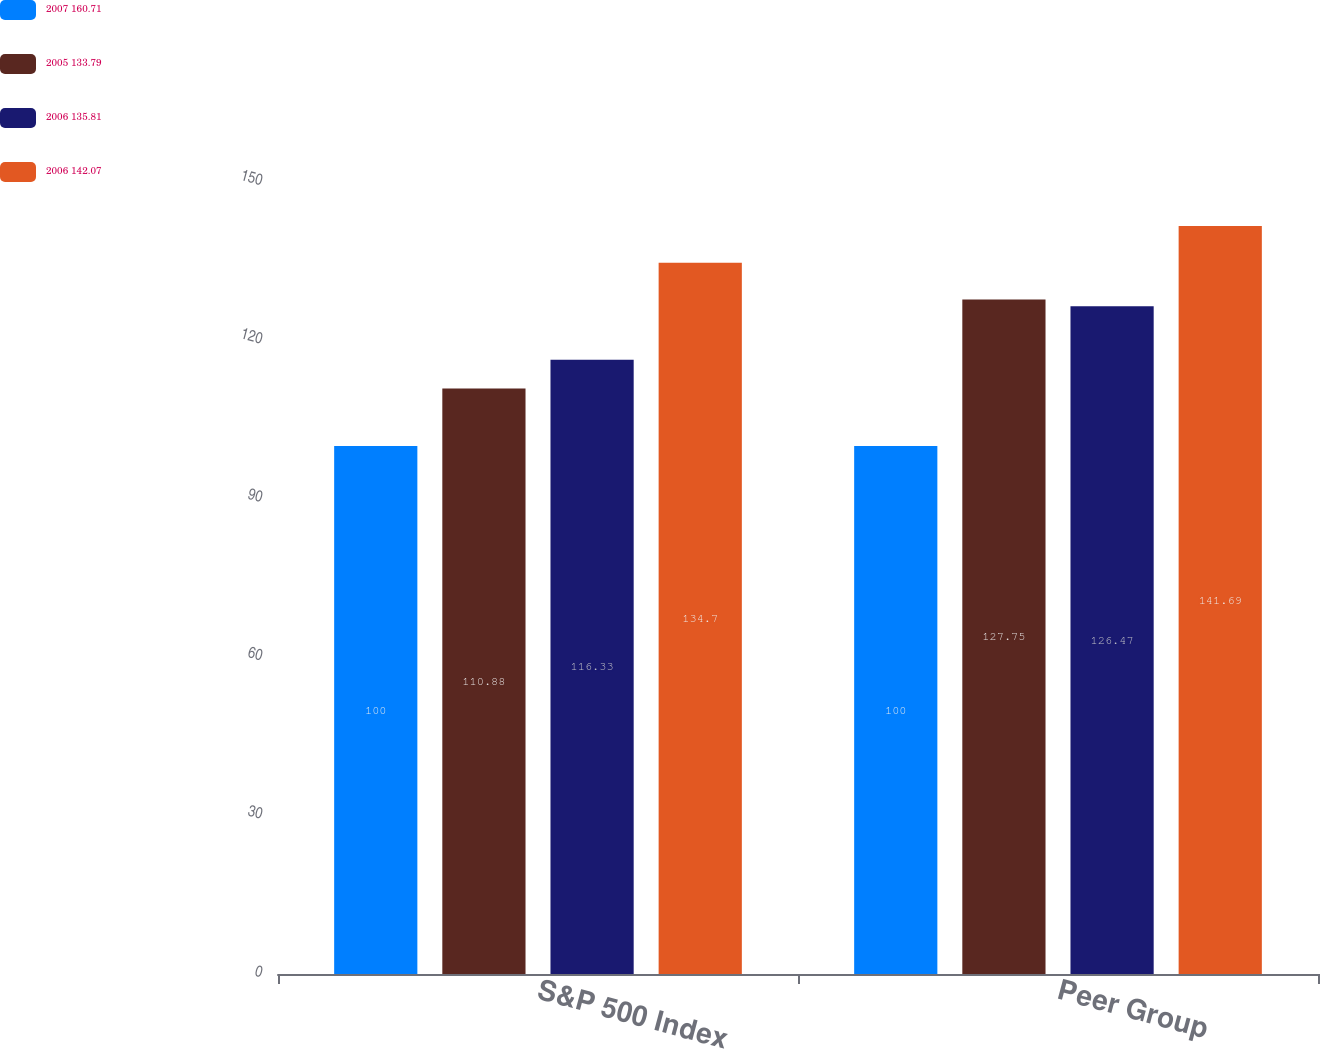Convert chart. <chart><loc_0><loc_0><loc_500><loc_500><stacked_bar_chart><ecel><fcel>S&P 500 Index<fcel>Peer Group<nl><fcel>2007 160.71<fcel>100<fcel>100<nl><fcel>2005 133.79<fcel>110.88<fcel>127.75<nl><fcel>2006 135.81<fcel>116.33<fcel>126.47<nl><fcel>2006 142.07<fcel>134.7<fcel>141.69<nl></chart> 